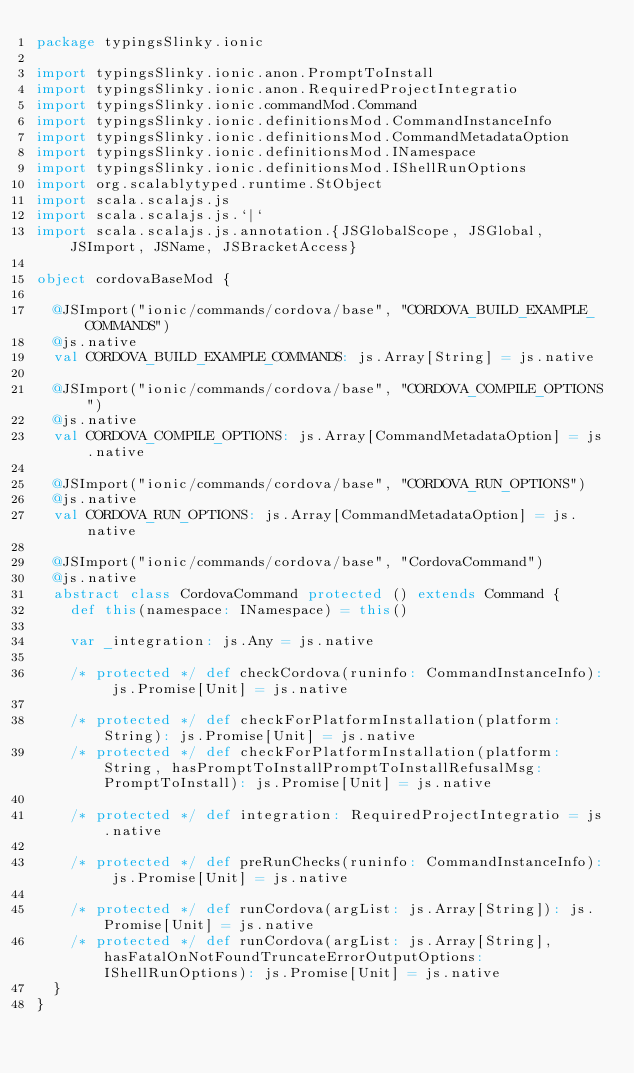Convert code to text. <code><loc_0><loc_0><loc_500><loc_500><_Scala_>package typingsSlinky.ionic

import typingsSlinky.ionic.anon.PromptToInstall
import typingsSlinky.ionic.anon.RequiredProjectIntegratio
import typingsSlinky.ionic.commandMod.Command
import typingsSlinky.ionic.definitionsMod.CommandInstanceInfo
import typingsSlinky.ionic.definitionsMod.CommandMetadataOption
import typingsSlinky.ionic.definitionsMod.INamespace
import typingsSlinky.ionic.definitionsMod.IShellRunOptions
import org.scalablytyped.runtime.StObject
import scala.scalajs.js
import scala.scalajs.js.`|`
import scala.scalajs.js.annotation.{JSGlobalScope, JSGlobal, JSImport, JSName, JSBracketAccess}

object cordovaBaseMod {
  
  @JSImport("ionic/commands/cordova/base", "CORDOVA_BUILD_EXAMPLE_COMMANDS")
  @js.native
  val CORDOVA_BUILD_EXAMPLE_COMMANDS: js.Array[String] = js.native
  
  @JSImport("ionic/commands/cordova/base", "CORDOVA_COMPILE_OPTIONS")
  @js.native
  val CORDOVA_COMPILE_OPTIONS: js.Array[CommandMetadataOption] = js.native
  
  @JSImport("ionic/commands/cordova/base", "CORDOVA_RUN_OPTIONS")
  @js.native
  val CORDOVA_RUN_OPTIONS: js.Array[CommandMetadataOption] = js.native
  
  @JSImport("ionic/commands/cordova/base", "CordovaCommand")
  @js.native
  abstract class CordovaCommand protected () extends Command {
    def this(namespace: INamespace) = this()
    
    var _integration: js.Any = js.native
    
    /* protected */ def checkCordova(runinfo: CommandInstanceInfo): js.Promise[Unit] = js.native
    
    /* protected */ def checkForPlatformInstallation(platform: String): js.Promise[Unit] = js.native
    /* protected */ def checkForPlatformInstallation(platform: String, hasPromptToInstallPromptToInstallRefusalMsg: PromptToInstall): js.Promise[Unit] = js.native
    
    /* protected */ def integration: RequiredProjectIntegratio = js.native
    
    /* protected */ def preRunChecks(runinfo: CommandInstanceInfo): js.Promise[Unit] = js.native
    
    /* protected */ def runCordova(argList: js.Array[String]): js.Promise[Unit] = js.native
    /* protected */ def runCordova(argList: js.Array[String], hasFatalOnNotFoundTruncateErrorOutputOptions: IShellRunOptions): js.Promise[Unit] = js.native
  }
}
</code> 